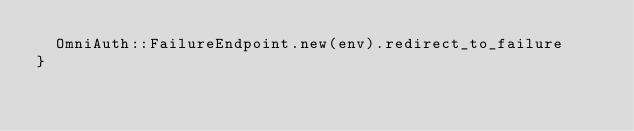Convert code to text. <code><loc_0><loc_0><loc_500><loc_500><_Ruby_>  OmniAuth::FailureEndpoint.new(env).redirect_to_failure
}
</code> 